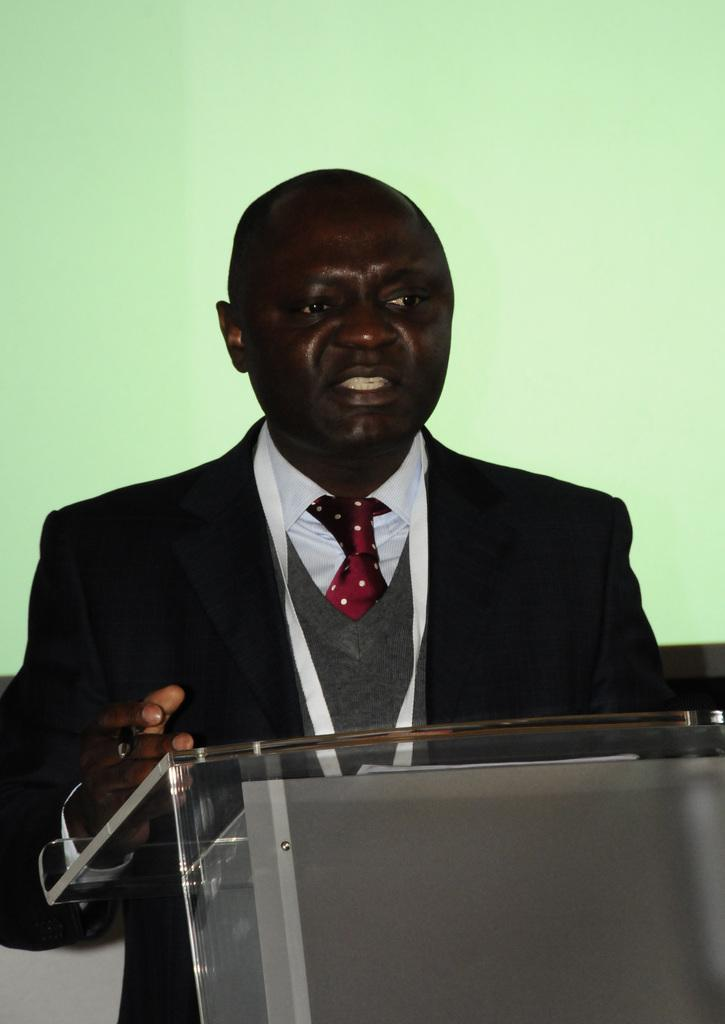Who is the main subject in the image? There is a man standing in the image. What is the man wearing? The man is wearing a black and white suit. What is the man holding in his hand? The man is holding a pen in his hand. What object is in front of the man? There is a podium in front of the man. Can you see the man's friend arguing with him in the image? There is no friend or argument present in the image; it only shows a man standing with a pen in his hand and a podium in front of him. 